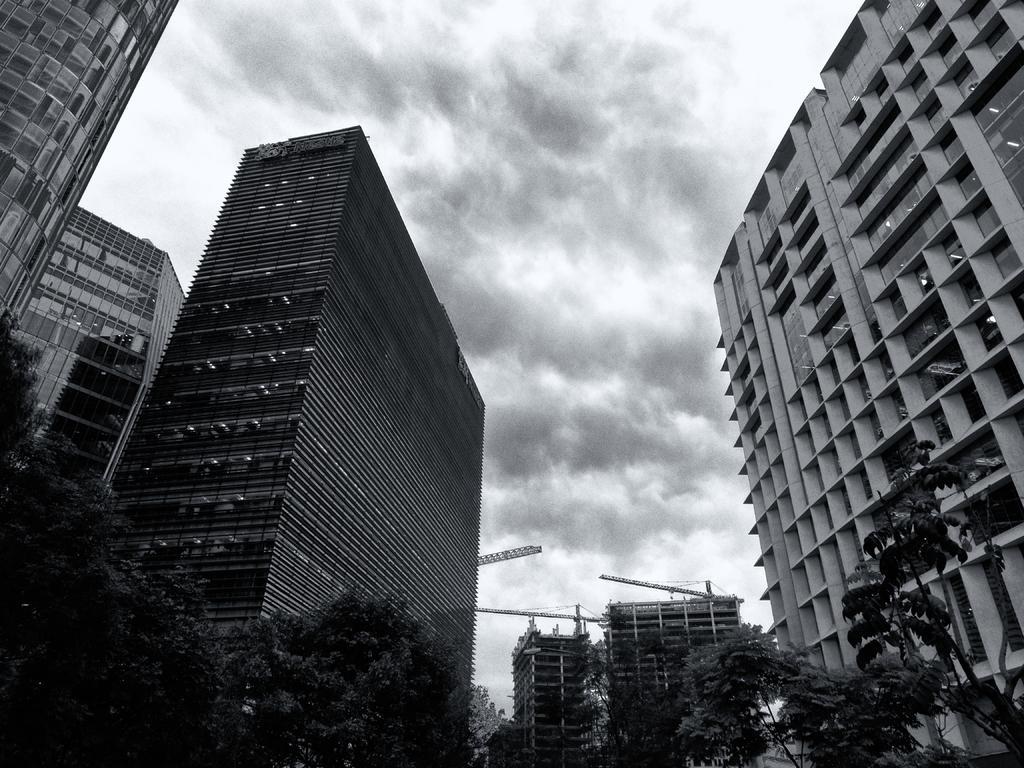Describe this image in one or two sentences. In this image there are buildings, trees and the sky. 